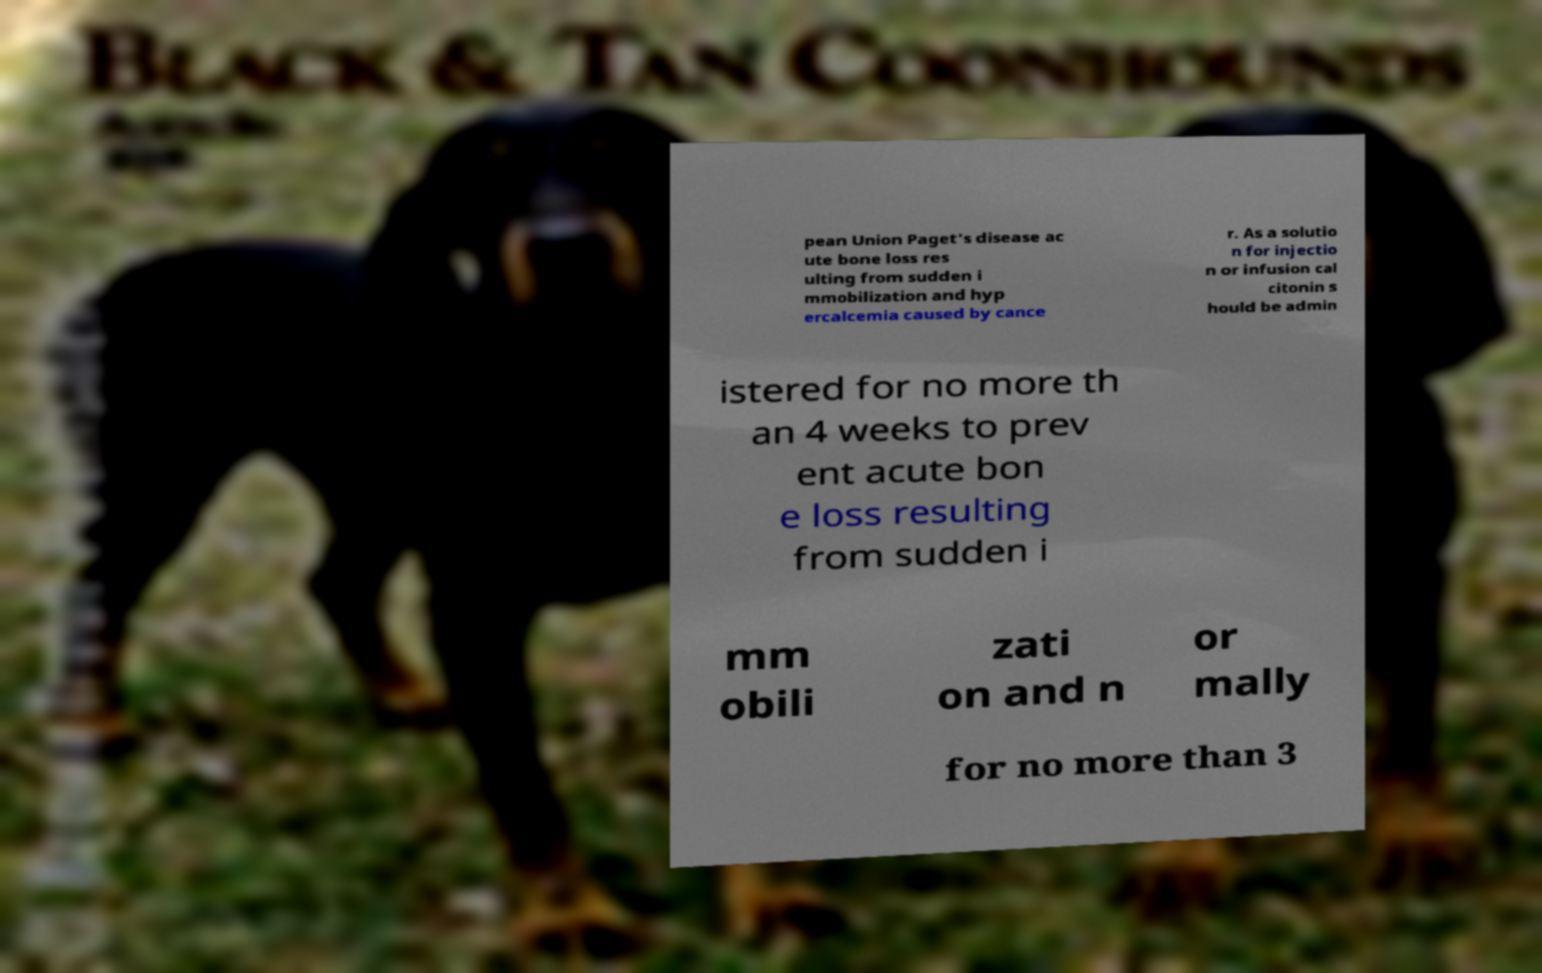Could you extract and type out the text from this image? pean Union Paget's disease ac ute bone loss res ulting from sudden i mmobilization and hyp ercalcemia caused by cance r. As a solutio n for injectio n or infusion cal citonin s hould be admin istered for no more th an 4 weeks to prev ent acute bon e loss resulting from sudden i mm obili zati on and n or mally for no more than 3 